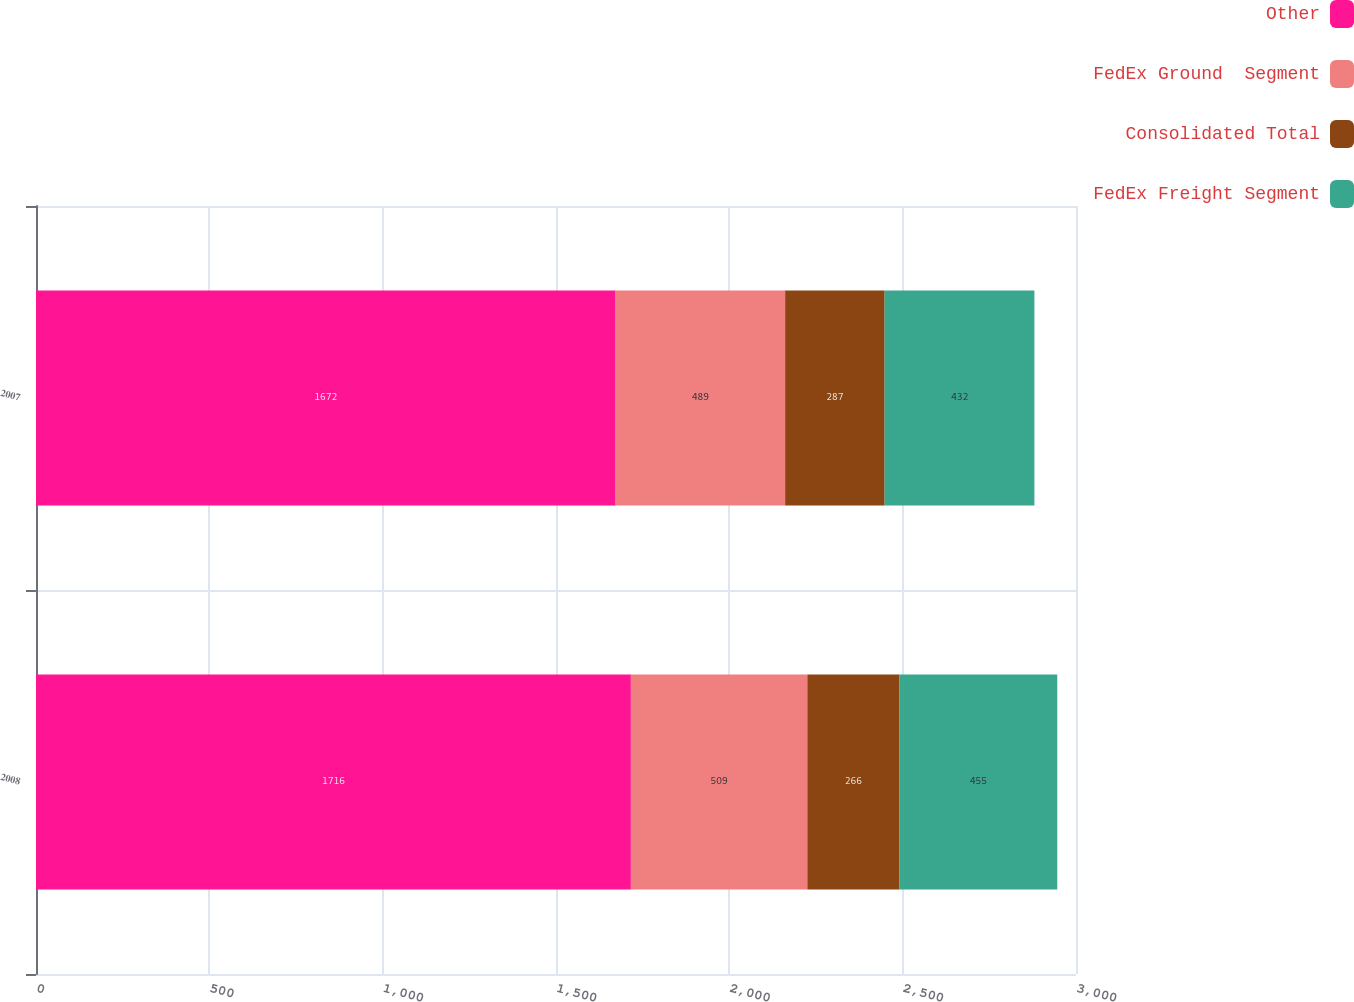Convert chart to OTSL. <chart><loc_0><loc_0><loc_500><loc_500><stacked_bar_chart><ecel><fcel>2008<fcel>2007<nl><fcel>Other<fcel>1716<fcel>1672<nl><fcel>FedEx Ground  Segment<fcel>509<fcel>489<nl><fcel>Consolidated Total<fcel>266<fcel>287<nl><fcel>FedEx Freight Segment<fcel>455<fcel>432<nl></chart> 